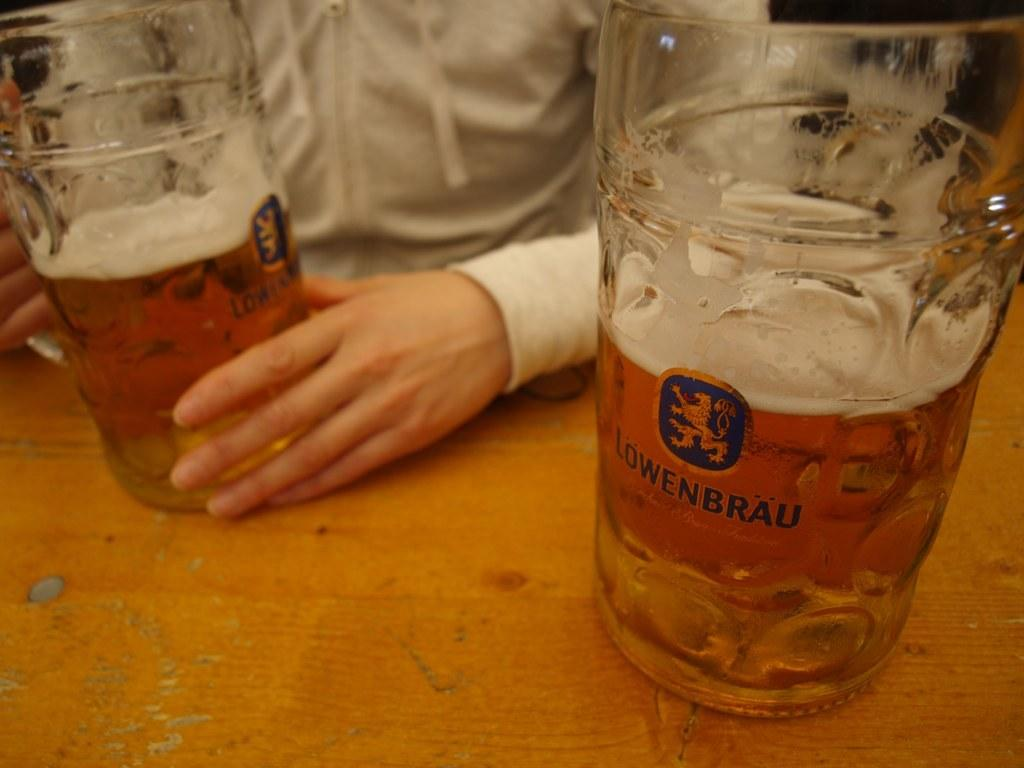<image>
Provide a brief description of the given image. Two glasses that are three quarters of the way full of a froth beer have then name Lowenbrau on the front of them. 